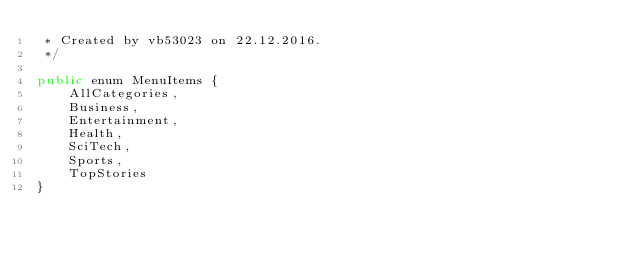<code> <loc_0><loc_0><loc_500><loc_500><_Java_> * Created by vb53023 on 22.12.2016.
 */

public enum MenuItems {
    AllCategories,
    Business,
    Entertainment,
    Health,
    SciTech,
    Sports,
    TopStories
}</code> 